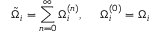Convert formula to latex. <formula><loc_0><loc_0><loc_500><loc_500>\tilde { \Omega } _ { i } = \sum _ { n = 0 } ^ { \infty } \Omega _ { i } ^ { ( n ) } , \Omega _ { i } ^ { ( 0 ) } = \Omega _ { i }</formula> 